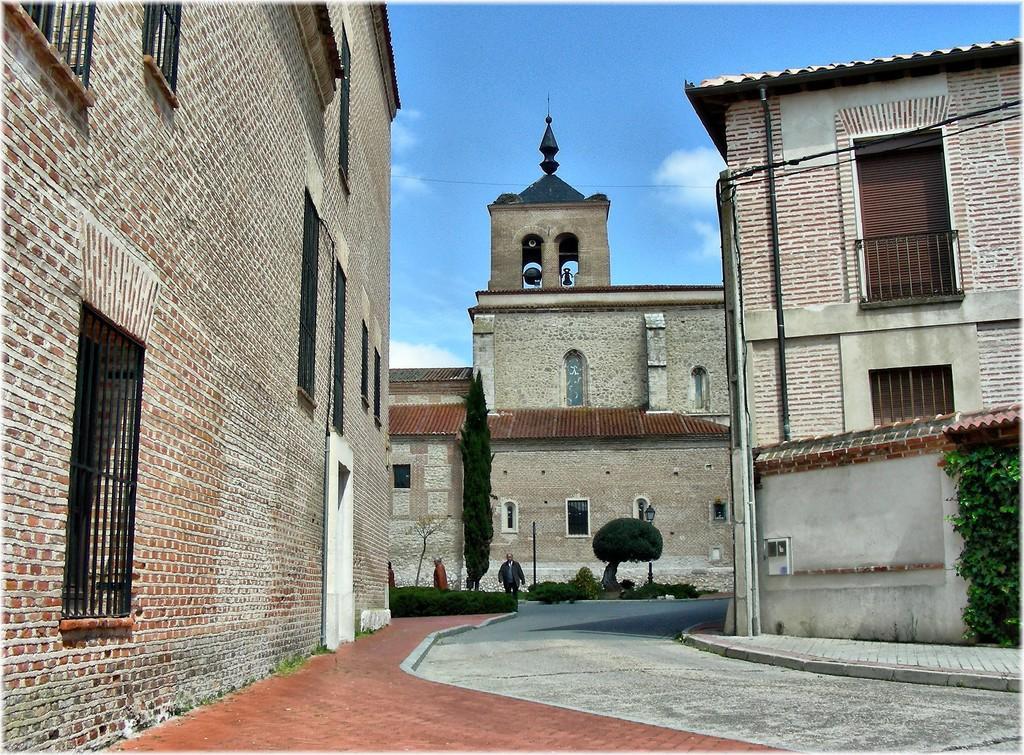Describe this image in one or two sentences. This image is taken outdoors. At the top of the image there is a sky with clouds. At the bottom of the image there is a road and there is a sidewalk. In this image there are three buildings with walls, windows, doors and roofs. In the middle of the image there are a few plants and two trees. A man is walking on the road. On the right side of the image there is a creeper. 